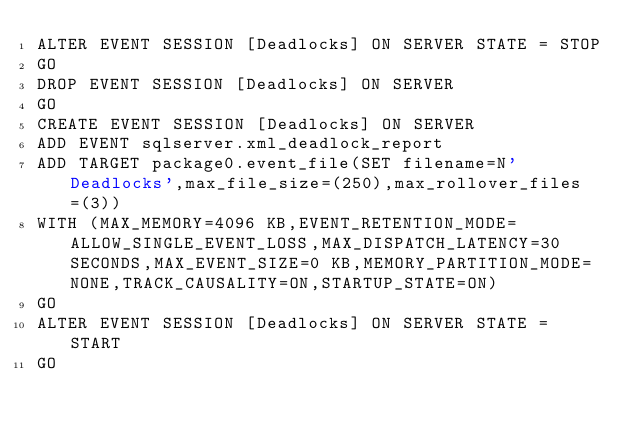<code> <loc_0><loc_0><loc_500><loc_500><_SQL_>ALTER EVENT SESSION [Deadlocks] ON SERVER STATE = STOP
GO
DROP EVENT SESSION [Deadlocks] ON SERVER 
GO
CREATE EVENT SESSION [Deadlocks] ON SERVER 
ADD EVENT sqlserver.xml_deadlock_report 
ADD TARGET package0.event_file(SET filename=N'Deadlocks',max_file_size=(250),max_rollover_files=(3))
WITH (MAX_MEMORY=4096 KB,EVENT_RETENTION_MODE=ALLOW_SINGLE_EVENT_LOSS,MAX_DISPATCH_LATENCY=30 SECONDS,MAX_EVENT_SIZE=0 KB,MEMORY_PARTITION_MODE=NONE,TRACK_CAUSALITY=ON,STARTUP_STATE=ON)
GO
ALTER EVENT SESSION [Deadlocks] ON SERVER STATE = START
GO
</code> 